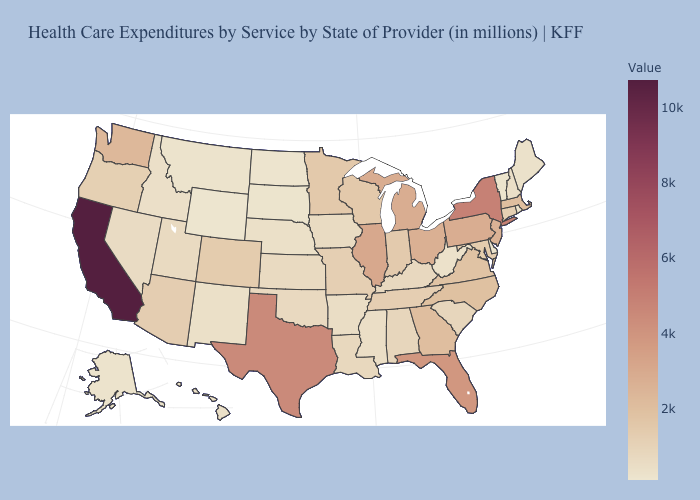Among the states that border Michigan , does Indiana have the lowest value?
Write a very short answer. Yes. Among the states that border Michigan , does Wisconsin have the highest value?
Short answer required. No. 